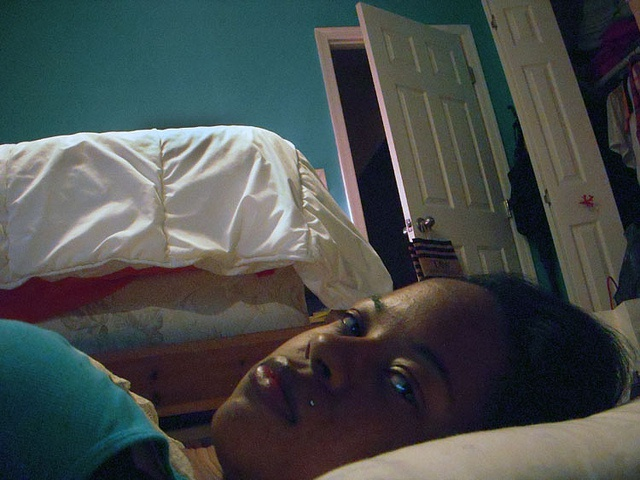Describe the objects in this image and their specific colors. I can see bed in black, gray, darkgray, and maroon tones, people in black, teal, and gray tones, and bed in black, darkgray, and gray tones in this image. 